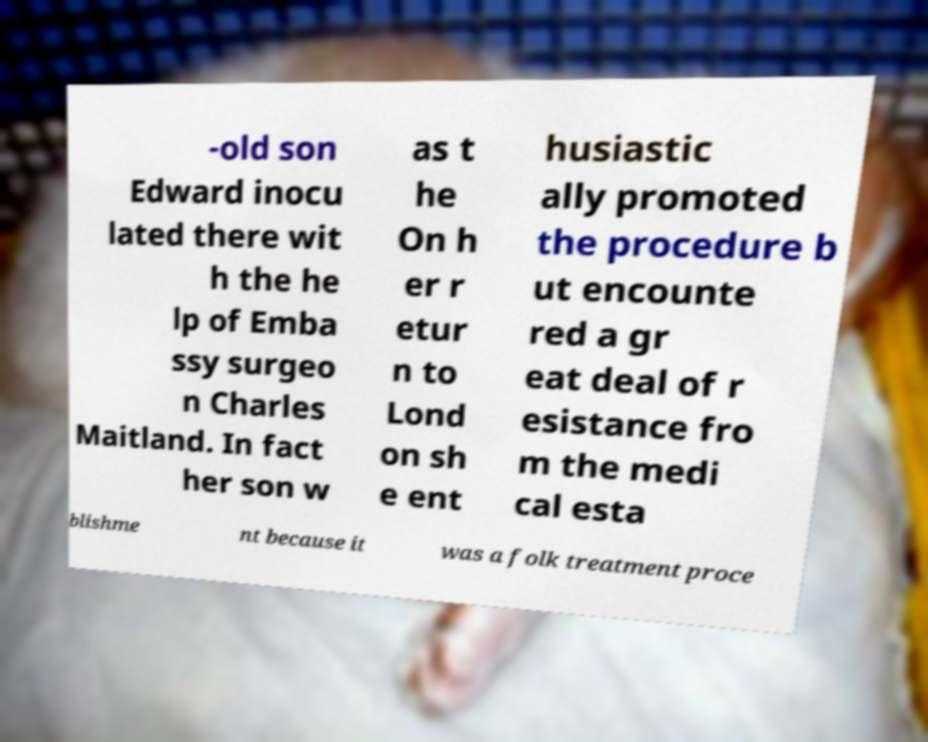Please identify and transcribe the text found in this image. -old son Edward inocu lated there wit h the he lp of Emba ssy surgeo n Charles Maitland. In fact her son w as t he On h er r etur n to Lond on sh e ent husiastic ally promoted the procedure b ut encounte red a gr eat deal of r esistance fro m the medi cal esta blishme nt because it was a folk treatment proce 